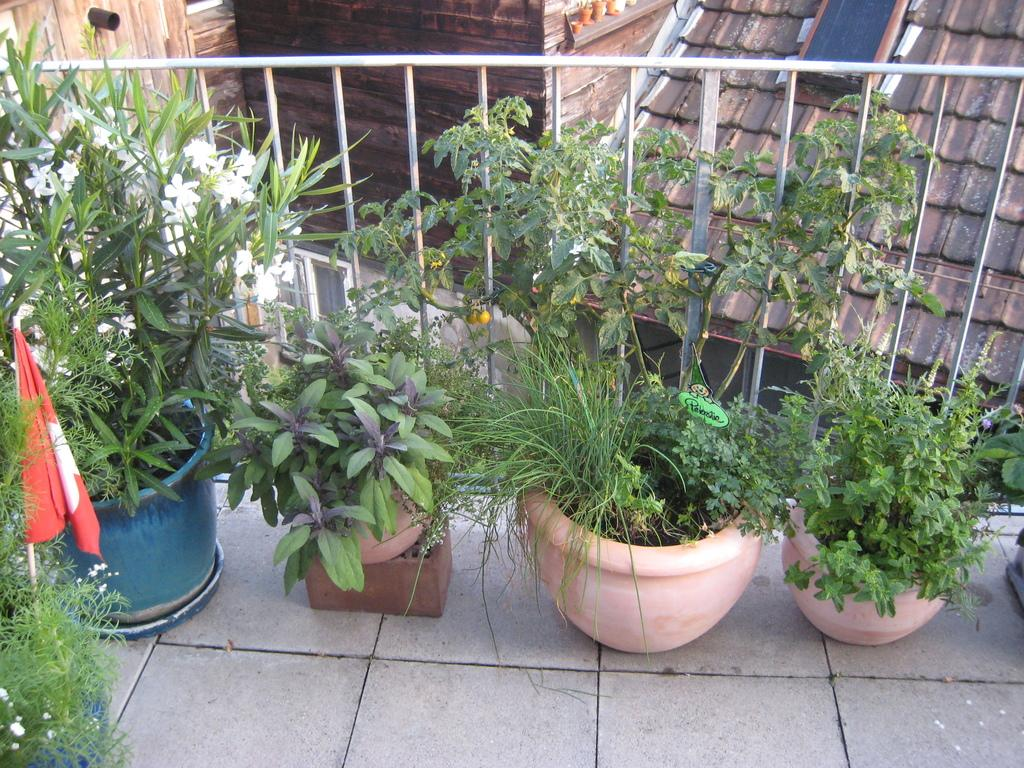What type of living organisms can be seen in the image? Plants can be seen in the image. How are the plants arranged or contained in the image? The plants are placed in flower pots. What type of barrier is present in the image? There is a fence in the image. What type of structures can be seen in the background of the image? There are sheds in the background of the image. Can you see a goose in the image? No, there is no goose present in the image. 